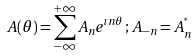<formula> <loc_0><loc_0><loc_500><loc_500>A ( \theta ) = \sum _ { - \infty } ^ { + \infty } A _ { n } e ^ { \imath n \theta } \, ; \, A _ { - n } = A _ { n } ^ { ^ { * } }</formula> 